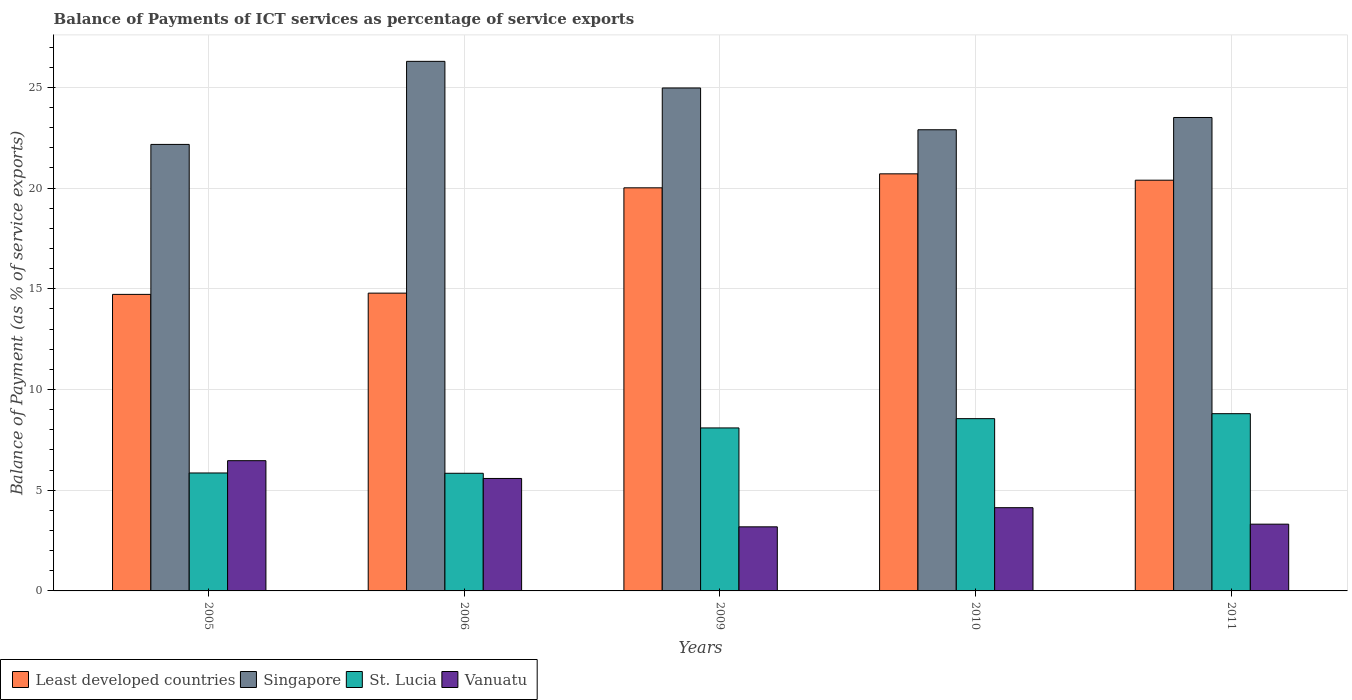How many different coloured bars are there?
Your response must be concise. 4. How many groups of bars are there?
Offer a terse response. 5. How many bars are there on the 4th tick from the left?
Offer a very short reply. 4. In how many cases, is the number of bars for a given year not equal to the number of legend labels?
Offer a very short reply. 0. What is the balance of payments of ICT services in Vanuatu in 2010?
Provide a short and direct response. 4.13. Across all years, what is the maximum balance of payments of ICT services in Vanuatu?
Give a very brief answer. 6.47. Across all years, what is the minimum balance of payments of ICT services in Vanuatu?
Your answer should be very brief. 3.18. In which year was the balance of payments of ICT services in Singapore minimum?
Make the answer very short. 2005. What is the total balance of payments of ICT services in Vanuatu in the graph?
Keep it short and to the point. 22.68. What is the difference between the balance of payments of ICT services in Singapore in 2006 and that in 2009?
Give a very brief answer. 1.32. What is the difference between the balance of payments of ICT services in St. Lucia in 2011 and the balance of payments of ICT services in Singapore in 2010?
Ensure brevity in your answer.  -14.1. What is the average balance of payments of ICT services in St. Lucia per year?
Ensure brevity in your answer.  7.43. In the year 2010, what is the difference between the balance of payments of ICT services in Least developed countries and balance of payments of ICT services in Singapore?
Ensure brevity in your answer.  -2.19. In how many years, is the balance of payments of ICT services in Singapore greater than 15 %?
Give a very brief answer. 5. What is the ratio of the balance of payments of ICT services in Least developed countries in 2009 to that in 2011?
Your answer should be very brief. 0.98. What is the difference between the highest and the second highest balance of payments of ICT services in Vanuatu?
Ensure brevity in your answer.  0.88. What is the difference between the highest and the lowest balance of payments of ICT services in Vanuatu?
Keep it short and to the point. 3.28. Is the sum of the balance of payments of ICT services in Least developed countries in 2006 and 2009 greater than the maximum balance of payments of ICT services in Vanuatu across all years?
Your answer should be compact. Yes. Is it the case that in every year, the sum of the balance of payments of ICT services in Singapore and balance of payments of ICT services in Least developed countries is greater than the sum of balance of payments of ICT services in Vanuatu and balance of payments of ICT services in St. Lucia?
Keep it short and to the point. No. What does the 2nd bar from the left in 2011 represents?
Your answer should be compact. Singapore. What does the 1st bar from the right in 2011 represents?
Keep it short and to the point. Vanuatu. Is it the case that in every year, the sum of the balance of payments of ICT services in Least developed countries and balance of payments of ICT services in Singapore is greater than the balance of payments of ICT services in Vanuatu?
Your answer should be compact. Yes. How many bars are there?
Your answer should be compact. 20. Are the values on the major ticks of Y-axis written in scientific E-notation?
Your answer should be very brief. No. Where does the legend appear in the graph?
Your answer should be compact. Bottom left. What is the title of the graph?
Your answer should be very brief. Balance of Payments of ICT services as percentage of service exports. What is the label or title of the X-axis?
Offer a terse response. Years. What is the label or title of the Y-axis?
Give a very brief answer. Balance of Payment (as % of service exports). What is the Balance of Payment (as % of service exports) in Least developed countries in 2005?
Give a very brief answer. 14.72. What is the Balance of Payment (as % of service exports) of Singapore in 2005?
Keep it short and to the point. 22.17. What is the Balance of Payment (as % of service exports) in St. Lucia in 2005?
Offer a terse response. 5.86. What is the Balance of Payment (as % of service exports) in Vanuatu in 2005?
Offer a very short reply. 6.47. What is the Balance of Payment (as % of service exports) of Least developed countries in 2006?
Your answer should be very brief. 14.78. What is the Balance of Payment (as % of service exports) in Singapore in 2006?
Give a very brief answer. 26.29. What is the Balance of Payment (as % of service exports) of St. Lucia in 2006?
Give a very brief answer. 5.84. What is the Balance of Payment (as % of service exports) in Vanuatu in 2006?
Ensure brevity in your answer.  5.58. What is the Balance of Payment (as % of service exports) of Least developed countries in 2009?
Ensure brevity in your answer.  20.01. What is the Balance of Payment (as % of service exports) in Singapore in 2009?
Offer a very short reply. 24.97. What is the Balance of Payment (as % of service exports) in St. Lucia in 2009?
Your answer should be very brief. 8.09. What is the Balance of Payment (as % of service exports) of Vanuatu in 2009?
Offer a terse response. 3.18. What is the Balance of Payment (as % of service exports) of Least developed countries in 2010?
Your answer should be very brief. 20.71. What is the Balance of Payment (as % of service exports) of Singapore in 2010?
Offer a very short reply. 22.9. What is the Balance of Payment (as % of service exports) in St. Lucia in 2010?
Provide a succinct answer. 8.55. What is the Balance of Payment (as % of service exports) of Vanuatu in 2010?
Offer a terse response. 4.13. What is the Balance of Payment (as % of service exports) in Least developed countries in 2011?
Ensure brevity in your answer.  20.39. What is the Balance of Payment (as % of service exports) in Singapore in 2011?
Your answer should be very brief. 23.5. What is the Balance of Payment (as % of service exports) of St. Lucia in 2011?
Offer a terse response. 8.8. What is the Balance of Payment (as % of service exports) in Vanuatu in 2011?
Provide a succinct answer. 3.31. Across all years, what is the maximum Balance of Payment (as % of service exports) of Least developed countries?
Provide a succinct answer. 20.71. Across all years, what is the maximum Balance of Payment (as % of service exports) of Singapore?
Your response must be concise. 26.29. Across all years, what is the maximum Balance of Payment (as % of service exports) in St. Lucia?
Your answer should be very brief. 8.8. Across all years, what is the maximum Balance of Payment (as % of service exports) in Vanuatu?
Keep it short and to the point. 6.47. Across all years, what is the minimum Balance of Payment (as % of service exports) of Least developed countries?
Offer a terse response. 14.72. Across all years, what is the minimum Balance of Payment (as % of service exports) of Singapore?
Keep it short and to the point. 22.17. Across all years, what is the minimum Balance of Payment (as % of service exports) in St. Lucia?
Provide a succinct answer. 5.84. Across all years, what is the minimum Balance of Payment (as % of service exports) in Vanuatu?
Your answer should be compact. 3.18. What is the total Balance of Payment (as % of service exports) of Least developed countries in the graph?
Your answer should be very brief. 90.62. What is the total Balance of Payment (as % of service exports) of Singapore in the graph?
Give a very brief answer. 119.83. What is the total Balance of Payment (as % of service exports) of St. Lucia in the graph?
Keep it short and to the point. 37.14. What is the total Balance of Payment (as % of service exports) of Vanuatu in the graph?
Your answer should be very brief. 22.68. What is the difference between the Balance of Payment (as % of service exports) of Least developed countries in 2005 and that in 2006?
Your answer should be very brief. -0.06. What is the difference between the Balance of Payment (as % of service exports) of Singapore in 2005 and that in 2006?
Provide a succinct answer. -4.12. What is the difference between the Balance of Payment (as % of service exports) of St. Lucia in 2005 and that in 2006?
Keep it short and to the point. 0.01. What is the difference between the Balance of Payment (as % of service exports) of Vanuatu in 2005 and that in 2006?
Keep it short and to the point. 0.88. What is the difference between the Balance of Payment (as % of service exports) of Least developed countries in 2005 and that in 2009?
Your answer should be compact. -5.29. What is the difference between the Balance of Payment (as % of service exports) of Singapore in 2005 and that in 2009?
Provide a succinct answer. -2.8. What is the difference between the Balance of Payment (as % of service exports) in St. Lucia in 2005 and that in 2009?
Offer a very short reply. -2.24. What is the difference between the Balance of Payment (as % of service exports) of Vanuatu in 2005 and that in 2009?
Keep it short and to the point. 3.28. What is the difference between the Balance of Payment (as % of service exports) of Least developed countries in 2005 and that in 2010?
Keep it short and to the point. -5.98. What is the difference between the Balance of Payment (as % of service exports) in Singapore in 2005 and that in 2010?
Give a very brief answer. -0.73. What is the difference between the Balance of Payment (as % of service exports) in St. Lucia in 2005 and that in 2010?
Keep it short and to the point. -2.7. What is the difference between the Balance of Payment (as % of service exports) of Vanuatu in 2005 and that in 2010?
Provide a succinct answer. 2.33. What is the difference between the Balance of Payment (as % of service exports) in Least developed countries in 2005 and that in 2011?
Provide a succinct answer. -5.67. What is the difference between the Balance of Payment (as % of service exports) of Singapore in 2005 and that in 2011?
Ensure brevity in your answer.  -1.34. What is the difference between the Balance of Payment (as % of service exports) of St. Lucia in 2005 and that in 2011?
Make the answer very short. -2.94. What is the difference between the Balance of Payment (as % of service exports) in Vanuatu in 2005 and that in 2011?
Offer a terse response. 3.15. What is the difference between the Balance of Payment (as % of service exports) of Least developed countries in 2006 and that in 2009?
Your answer should be very brief. -5.23. What is the difference between the Balance of Payment (as % of service exports) of Singapore in 2006 and that in 2009?
Provide a short and direct response. 1.32. What is the difference between the Balance of Payment (as % of service exports) in St. Lucia in 2006 and that in 2009?
Provide a succinct answer. -2.25. What is the difference between the Balance of Payment (as % of service exports) of Vanuatu in 2006 and that in 2009?
Give a very brief answer. 2.4. What is the difference between the Balance of Payment (as % of service exports) in Least developed countries in 2006 and that in 2010?
Your answer should be compact. -5.92. What is the difference between the Balance of Payment (as % of service exports) of Singapore in 2006 and that in 2010?
Provide a succinct answer. 3.4. What is the difference between the Balance of Payment (as % of service exports) in St. Lucia in 2006 and that in 2010?
Provide a short and direct response. -2.71. What is the difference between the Balance of Payment (as % of service exports) of Vanuatu in 2006 and that in 2010?
Ensure brevity in your answer.  1.45. What is the difference between the Balance of Payment (as % of service exports) of Least developed countries in 2006 and that in 2011?
Give a very brief answer. -5.61. What is the difference between the Balance of Payment (as % of service exports) in Singapore in 2006 and that in 2011?
Provide a succinct answer. 2.79. What is the difference between the Balance of Payment (as % of service exports) in St. Lucia in 2006 and that in 2011?
Your answer should be very brief. -2.96. What is the difference between the Balance of Payment (as % of service exports) in Vanuatu in 2006 and that in 2011?
Provide a short and direct response. 2.27. What is the difference between the Balance of Payment (as % of service exports) of Least developed countries in 2009 and that in 2010?
Make the answer very short. -0.69. What is the difference between the Balance of Payment (as % of service exports) in Singapore in 2009 and that in 2010?
Ensure brevity in your answer.  2.07. What is the difference between the Balance of Payment (as % of service exports) in St. Lucia in 2009 and that in 2010?
Your answer should be compact. -0.46. What is the difference between the Balance of Payment (as % of service exports) in Vanuatu in 2009 and that in 2010?
Offer a terse response. -0.95. What is the difference between the Balance of Payment (as % of service exports) of Least developed countries in 2009 and that in 2011?
Your answer should be compact. -0.38. What is the difference between the Balance of Payment (as % of service exports) of Singapore in 2009 and that in 2011?
Keep it short and to the point. 1.47. What is the difference between the Balance of Payment (as % of service exports) of St. Lucia in 2009 and that in 2011?
Give a very brief answer. -0.71. What is the difference between the Balance of Payment (as % of service exports) in Vanuatu in 2009 and that in 2011?
Your answer should be very brief. -0.13. What is the difference between the Balance of Payment (as % of service exports) in Least developed countries in 2010 and that in 2011?
Your answer should be compact. 0.32. What is the difference between the Balance of Payment (as % of service exports) of Singapore in 2010 and that in 2011?
Your response must be concise. -0.61. What is the difference between the Balance of Payment (as % of service exports) of St. Lucia in 2010 and that in 2011?
Provide a succinct answer. -0.25. What is the difference between the Balance of Payment (as % of service exports) in Vanuatu in 2010 and that in 2011?
Your response must be concise. 0.82. What is the difference between the Balance of Payment (as % of service exports) in Least developed countries in 2005 and the Balance of Payment (as % of service exports) in Singapore in 2006?
Your response must be concise. -11.57. What is the difference between the Balance of Payment (as % of service exports) of Least developed countries in 2005 and the Balance of Payment (as % of service exports) of St. Lucia in 2006?
Offer a very short reply. 8.88. What is the difference between the Balance of Payment (as % of service exports) of Least developed countries in 2005 and the Balance of Payment (as % of service exports) of Vanuatu in 2006?
Keep it short and to the point. 9.14. What is the difference between the Balance of Payment (as % of service exports) in Singapore in 2005 and the Balance of Payment (as % of service exports) in St. Lucia in 2006?
Make the answer very short. 16.33. What is the difference between the Balance of Payment (as % of service exports) in Singapore in 2005 and the Balance of Payment (as % of service exports) in Vanuatu in 2006?
Your answer should be compact. 16.58. What is the difference between the Balance of Payment (as % of service exports) in St. Lucia in 2005 and the Balance of Payment (as % of service exports) in Vanuatu in 2006?
Make the answer very short. 0.27. What is the difference between the Balance of Payment (as % of service exports) of Least developed countries in 2005 and the Balance of Payment (as % of service exports) of Singapore in 2009?
Offer a very short reply. -10.25. What is the difference between the Balance of Payment (as % of service exports) of Least developed countries in 2005 and the Balance of Payment (as % of service exports) of St. Lucia in 2009?
Keep it short and to the point. 6.63. What is the difference between the Balance of Payment (as % of service exports) in Least developed countries in 2005 and the Balance of Payment (as % of service exports) in Vanuatu in 2009?
Keep it short and to the point. 11.54. What is the difference between the Balance of Payment (as % of service exports) in Singapore in 2005 and the Balance of Payment (as % of service exports) in St. Lucia in 2009?
Ensure brevity in your answer.  14.08. What is the difference between the Balance of Payment (as % of service exports) in Singapore in 2005 and the Balance of Payment (as % of service exports) in Vanuatu in 2009?
Keep it short and to the point. 18.99. What is the difference between the Balance of Payment (as % of service exports) in St. Lucia in 2005 and the Balance of Payment (as % of service exports) in Vanuatu in 2009?
Make the answer very short. 2.67. What is the difference between the Balance of Payment (as % of service exports) of Least developed countries in 2005 and the Balance of Payment (as % of service exports) of Singapore in 2010?
Make the answer very short. -8.17. What is the difference between the Balance of Payment (as % of service exports) in Least developed countries in 2005 and the Balance of Payment (as % of service exports) in St. Lucia in 2010?
Your response must be concise. 6.17. What is the difference between the Balance of Payment (as % of service exports) in Least developed countries in 2005 and the Balance of Payment (as % of service exports) in Vanuatu in 2010?
Your answer should be very brief. 10.59. What is the difference between the Balance of Payment (as % of service exports) in Singapore in 2005 and the Balance of Payment (as % of service exports) in St. Lucia in 2010?
Provide a short and direct response. 13.61. What is the difference between the Balance of Payment (as % of service exports) of Singapore in 2005 and the Balance of Payment (as % of service exports) of Vanuatu in 2010?
Your answer should be very brief. 18.04. What is the difference between the Balance of Payment (as % of service exports) of St. Lucia in 2005 and the Balance of Payment (as % of service exports) of Vanuatu in 2010?
Your answer should be compact. 1.72. What is the difference between the Balance of Payment (as % of service exports) in Least developed countries in 2005 and the Balance of Payment (as % of service exports) in Singapore in 2011?
Provide a short and direct response. -8.78. What is the difference between the Balance of Payment (as % of service exports) of Least developed countries in 2005 and the Balance of Payment (as % of service exports) of St. Lucia in 2011?
Your answer should be compact. 5.92. What is the difference between the Balance of Payment (as % of service exports) in Least developed countries in 2005 and the Balance of Payment (as % of service exports) in Vanuatu in 2011?
Ensure brevity in your answer.  11.41. What is the difference between the Balance of Payment (as % of service exports) in Singapore in 2005 and the Balance of Payment (as % of service exports) in St. Lucia in 2011?
Keep it short and to the point. 13.37. What is the difference between the Balance of Payment (as % of service exports) in Singapore in 2005 and the Balance of Payment (as % of service exports) in Vanuatu in 2011?
Your response must be concise. 18.85. What is the difference between the Balance of Payment (as % of service exports) in St. Lucia in 2005 and the Balance of Payment (as % of service exports) in Vanuatu in 2011?
Offer a very short reply. 2.54. What is the difference between the Balance of Payment (as % of service exports) of Least developed countries in 2006 and the Balance of Payment (as % of service exports) of Singapore in 2009?
Make the answer very short. -10.19. What is the difference between the Balance of Payment (as % of service exports) of Least developed countries in 2006 and the Balance of Payment (as % of service exports) of St. Lucia in 2009?
Provide a short and direct response. 6.69. What is the difference between the Balance of Payment (as % of service exports) of Least developed countries in 2006 and the Balance of Payment (as % of service exports) of Vanuatu in 2009?
Provide a short and direct response. 11.6. What is the difference between the Balance of Payment (as % of service exports) in Singapore in 2006 and the Balance of Payment (as % of service exports) in St. Lucia in 2009?
Your answer should be very brief. 18.2. What is the difference between the Balance of Payment (as % of service exports) in Singapore in 2006 and the Balance of Payment (as % of service exports) in Vanuatu in 2009?
Ensure brevity in your answer.  23.11. What is the difference between the Balance of Payment (as % of service exports) of St. Lucia in 2006 and the Balance of Payment (as % of service exports) of Vanuatu in 2009?
Your answer should be compact. 2.66. What is the difference between the Balance of Payment (as % of service exports) of Least developed countries in 2006 and the Balance of Payment (as % of service exports) of Singapore in 2010?
Provide a succinct answer. -8.11. What is the difference between the Balance of Payment (as % of service exports) in Least developed countries in 2006 and the Balance of Payment (as % of service exports) in St. Lucia in 2010?
Give a very brief answer. 6.23. What is the difference between the Balance of Payment (as % of service exports) of Least developed countries in 2006 and the Balance of Payment (as % of service exports) of Vanuatu in 2010?
Keep it short and to the point. 10.65. What is the difference between the Balance of Payment (as % of service exports) in Singapore in 2006 and the Balance of Payment (as % of service exports) in St. Lucia in 2010?
Your answer should be very brief. 17.74. What is the difference between the Balance of Payment (as % of service exports) in Singapore in 2006 and the Balance of Payment (as % of service exports) in Vanuatu in 2010?
Offer a very short reply. 22.16. What is the difference between the Balance of Payment (as % of service exports) in St. Lucia in 2006 and the Balance of Payment (as % of service exports) in Vanuatu in 2010?
Your response must be concise. 1.71. What is the difference between the Balance of Payment (as % of service exports) of Least developed countries in 2006 and the Balance of Payment (as % of service exports) of Singapore in 2011?
Your response must be concise. -8.72. What is the difference between the Balance of Payment (as % of service exports) of Least developed countries in 2006 and the Balance of Payment (as % of service exports) of St. Lucia in 2011?
Offer a terse response. 5.99. What is the difference between the Balance of Payment (as % of service exports) in Least developed countries in 2006 and the Balance of Payment (as % of service exports) in Vanuatu in 2011?
Make the answer very short. 11.47. What is the difference between the Balance of Payment (as % of service exports) of Singapore in 2006 and the Balance of Payment (as % of service exports) of St. Lucia in 2011?
Keep it short and to the point. 17.49. What is the difference between the Balance of Payment (as % of service exports) of Singapore in 2006 and the Balance of Payment (as % of service exports) of Vanuatu in 2011?
Provide a short and direct response. 22.98. What is the difference between the Balance of Payment (as % of service exports) in St. Lucia in 2006 and the Balance of Payment (as % of service exports) in Vanuatu in 2011?
Offer a terse response. 2.53. What is the difference between the Balance of Payment (as % of service exports) of Least developed countries in 2009 and the Balance of Payment (as % of service exports) of Singapore in 2010?
Your response must be concise. -2.88. What is the difference between the Balance of Payment (as % of service exports) of Least developed countries in 2009 and the Balance of Payment (as % of service exports) of St. Lucia in 2010?
Keep it short and to the point. 11.46. What is the difference between the Balance of Payment (as % of service exports) in Least developed countries in 2009 and the Balance of Payment (as % of service exports) in Vanuatu in 2010?
Provide a short and direct response. 15.88. What is the difference between the Balance of Payment (as % of service exports) in Singapore in 2009 and the Balance of Payment (as % of service exports) in St. Lucia in 2010?
Provide a succinct answer. 16.42. What is the difference between the Balance of Payment (as % of service exports) in Singapore in 2009 and the Balance of Payment (as % of service exports) in Vanuatu in 2010?
Keep it short and to the point. 20.84. What is the difference between the Balance of Payment (as % of service exports) of St. Lucia in 2009 and the Balance of Payment (as % of service exports) of Vanuatu in 2010?
Your answer should be very brief. 3.96. What is the difference between the Balance of Payment (as % of service exports) in Least developed countries in 2009 and the Balance of Payment (as % of service exports) in Singapore in 2011?
Your answer should be very brief. -3.49. What is the difference between the Balance of Payment (as % of service exports) of Least developed countries in 2009 and the Balance of Payment (as % of service exports) of St. Lucia in 2011?
Your answer should be compact. 11.21. What is the difference between the Balance of Payment (as % of service exports) of Least developed countries in 2009 and the Balance of Payment (as % of service exports) of Vanuatu in 2011?
Ensure brevity in your answer.  16.7. What is the difference between the Balance of Payment (as % of service exports) in Singapore in 2009 and the Balance of Payment (as % of service exports) in St. Lucia in 2011?
Your answer should be compact. 16.17. What is the difference between the Balance of Payment (as % of service exports) of Singapore in 2009 and the Balance of Payment (as % of service exports) of Vanuatu in 2011?
Offer a terse response. 21.66. What is the difference between the Balance of Payment (as % of service exports) in St. Lucia in 2009 and the Balance of Payment (as % of service exports) in Vanuatu in 2011?
Your answer should be very brief. 4.78. What is the difference between the Balance of Payment (as % of service exports) in Least developed countries in 2010 and the Balance of Payment (as % of service exports) in Singapore in 2011?
Offer a terse response. -2.8. What is the difference between the Balance of Payment (as % of service exports) of Least developed countries in 2010 and the Balance of Payment (as % of service exports) of St. Lucia in 2011?
Ensure brevity in your answer.  11.91. What is the difference between the Balance of Payment (as % of service exports) in Least developed countries in 2010 and the Balance of Payment (as % of service exports) in Vanuatu in 2011?
Your answer should be very brief. 17.39. What is the difference between the Balance of Payment (as % of service exports) of Singapore in 2010 and the Balance of Payment (as % of service exports) of St. Lucia in 2011?
Offer a very short reply. 14.1. What is the difference between the Balance of Payment (as % of service exports) in Singapore in 2010 and the Balance of Payment (as % of service exports) in Vanuatu in 2011?
Your answer should be compact. 19.58. What is the difference between the Balance of Payment (as % of service exports) of St. Lucia in 2010 and the Balance of Payment (as % of service exports) of Vanuatu in 2011?
Your response must be concise. 5.24. What is the average Balance of Payment (as % of service exports) of Least developed countries per year?
Offer a terse response. 18.12. What is the average Balance of Payment (as % of service exports) of Singapore per year?
Provide a succinct answer. 23.97. What is the average Balance of Payment (as % of service exports) in St. Lucia per year?
Provide a succinct answer. 7.43. What is the average Balance of Payment (as % of service exports) of Vanuatu per year?
Ensure brevity in your answer.  4.54. In the year 2005, what is the difference between the Balance of Payment (as % of service exports) of Least developed countries and Balance of Payment (as % of service exports) of Singapore?
Keep it short and to the point. -7.45. In the year 2005, what is the difference between the Balance of Payment (as % of service exports) in Least developed countries and Balance of Payment (as % of service exports) in St. Lucia?
Offer a very short reply. 8.87. In the year 2005, what is the difference between the Balance of Payment (as % of service exports) in Least developed countries and Balance of Payment (as % of service exports) in Vanuatu?
Keep it short and to the point. 8.26. In the year 2005, what is the difference between the Balance of Payment (as % of service exports) in Singapore and Balance of Payment (as % of service exports) in St. Lucia?
Offer a terse response. 16.31. In the year 2005, what is the difference between the Balance of Payment (as % of service exports) of Singapore and Balance of Payment (as % of service exports) of Vanuatu?
Make the answer very short. 15.7. In the year 2005, what is the difference between the Balance of Payment (as % of service exports) of St. Lucia and Balance of Payment (as % of service exports) of Vanuatu?
Ensure brevity in your answer.  -0.61. In the year 2006, what is the difference between the Balance of Payment (as % of service exports) of Least developed countries and Balance of Payment (as % of service exports) of Singapore?
Keep it short and to the point. -11.51. In the year 2006, what is the difference between the Balance of Payment (as % of service exports) in Least developed countries and Balance of Payment (as % of service exports) in St. Lucia?
Provide a succinct answer. 8.94. In the year 2006, what is the difference between the Balance of Payment (as % of service exports) of Least developed countries and Balance of Payment (as % of service exports) of Vanuatu?
Provide a short and direct response. 9.2. In the year 2006, what is the difference between the Balance of Payment (as % of service exports) in Singapore and Balance of Payment (as % of service exports) in St. Lucia?
Your answer should be very brief. 20.45. In the year 2006, what is the difference between the Balance of Payment (as % of service exports) in Singapore and Balance of Payment (as % of service exports) in Vanuatu?
Give a very brief answer. 20.71. In the year 2006, what is the difference between the Balance of Payment (as % of service exports) in St. Lucia and Balance of Payment (as % of service exports) in Vanuatu?
Your answer should be compact. 0.26. In the year 2009, what is the difference between the Balance of Payment (as % of service exports) in Least developed countries and Balance of Payment (as % of service exports) in Singapore?
Make the answer very short. -4.96. In the year 2009, what is the difference between the Balance of Payment (as % of service exports) of Least developed countries and Balance of Payment (as % of service exports) of St. Lucia?
Make the answer very short. 11.92. In the year 2009, what is the difference between the Balance of Payment (as % of service exports) in Least developed countries and Balance of Payment (as % of service exports) in Vanuatu?
Offer a very short reply. 16.83. In the year 2009, what is the difference between the Balance of Payment (as % of service exports) in Singapore and Balance of Payment (as % of service exports) in St. Lucia?
Your response must be concise. 16.88. In the year 2009, what is the difference between the Balance of Payment (as % of service exports) of Singapore and Balance of Payment (as % of service exports) of Vanuatu?
Provide a short and direct response. 21.79. In the year 2009, what is the difference between the Balance of Payment (as % of service exports) of St. Lucia and Balance of Payment (as % of service exports) of Vanuatu?
Your answer should be compact. 4.91. In the year 2010, what is the difference between the Balance of Payment (as % of service exports) of Least developed countries and Balance of Payment (as % of service exports) of Singapore?
Offer a terse response. -2.19. In the year 2010, what is the difference between the Balance of Payment (as % of service exports) in Least developed countries and Balance of Payment (as % of service exports) in St. Lucia?
Your response must be concise. 12.15. In the year 2010, what is the difference between the Balance of Payment (as % of service exports) in Least developed countries and Balance of Payment (as % of service exports) in Vanuatu?
Provide a short and direct response. 16.57. In the year 2010, what is the difference between the Balance of Payment (as % of service exports) of Singapore and Balance of Payment (as % of service exports) of St. Lucia?
Provide a succinct answer. 14.34. In the year 2010, what is the difference between the Balance of Payment (as % of service exports) of Singapore and Balance of Payment (as % of service exports) of Vanuatu?
Your answer should be very brief. 18.76. In the year 2010, what is the difference between the Balance of Payment (as % of service exports) in St. Lucia and Balance of Payment (as % of service exports) in Vanuatu?
Keep it short and to the point. 4.42. In the year 2011, what is the difference between the Balance of Payment (as % of service exports) of Least developed countries and Balance of Payment (as % of service exports) of Singapore?
Give a very brief answer. -3.11. In the year 2011, what is the difference between the Balance of Payment (as % of service exports) of Least developed countries and Balance of Payment (as % of service exports) of St. Lucia?
Offer a terse response. 11.59. In the year 2011, what is the difference between the Balance of Payment (as % of service exports) in Least developed countries and Balance of Payment (as % of service exports) in Vanuatu?
Provide a succinct answer. 17.08. In the year 2011, what is the difference between the Balance of Payment (as % of service exports) in Singapore and Balance of Payment (as % of service exports) in St. Lucia?
Give a very brief answer. 14.71. In the year 2011, what is the difference between the Balance of Payment (as % of service exports) in Singapore and Balance of Payment (as % of service exports) in Vanuatu?
Your response must be concise. 20.19. In the year 2011, what is the difference between the Balance of Payment (as % of service exports) of St. Lucia and Balance of Payment (as % of service exports) of Vanuatu?
Offer a very short reply. 5.48. What is the ratio of the Balance of Payment (as % of service exports) of Singapore in 2005 to that in 2006?
Ensure brevity in your answer.  0.84. What is the ratio of the Balance of Payment (as % of service exports) of St. Lucia in 2005 to that in 2006?
Provide a succinct answer. 1. What is the ratio of the Balance of Payment (as % of service exports) of Vanuatu in 2005 to that in 2006?
Ensure brevity in your answer.  1.16. What is the ratio of the Balance of Payment (as % of service exports) of Least developed countries in 2005 to that in 2009?
Your answer should be compact. 0.74. What is the ratio of the Balance of Payment (as % of service exports) of Singapore in 2005 to that in 2009?
Give a very brief answer. 0.89. What is the ratio of the Balance of Payment (as % of service exports) in St. Lucia in 2005 to that in 2009?
Make the answer very short. 0.72. What is the ratio of the Balance of Payment (as % of service exports) of Vanuatu in 2005 to that in 2009?
Give a very brief answer. 2.03. What is the ratio of the Balance of Payment (as % of service exports) of Least developed countries in 2005 to that in 2010?
Your response must be concise. 0.71. What is the ratio of the Balance of Payment (as % of service exports) of Singapore in 2005 to that in 2010?
Offer a terse response. 0.97. What is the ratio of the Balance of Payment (as % of service exports) in St. Lucia in 2005 to that in 2010?
Offer a very short reply. 0.68. What is the ratio of the Balance of Payment (as % of service exports) of Vanuatu in 2005 to that in 2010?
Your response must be concise. 1.56. What is the ratio of the Balance of Payment (as % of service exports) in Least developed countries in 2005 to that in 2011?
Ensure brevity in your answer.  0.72. What is the ratio of the Balance of Payment (as % of service exports) in Singapore in 2005 to that in 2011?
Keep it short and to the point. 0.94. What is the ratio of the Balance of Payment (as % of service exports) in St. Lucia in 2005 to that in 2011?
Provide a succinct answer. 0.67. What is the ratio of the Balance of Payment (as % of service exports) in Vanuatu in 2005 to that in 2011?
Keep it short and to the point. 1.95. What is the ratio of the Balance of Payment (as % of service exports) of Least developed countries in 2006 to that in 2009?
Provide a succinct answer. 0.74. What is the ratio of the Balance of Payment (as % of service exports) in Singapore in 2006 to that in 2009?
Provide a short and direct response. 1.05. What is the ratio of the Balance of Payment (as % of service exports) in St. Lucia in 2006 to that in 2009?
Offer a very short reply. 0.72. What is the ratio of the Balance of Payment (as % of service exports) of Vanuatu in 2006 to that in 2009?
Give a very brief answer. 1.75. What is the ratio of the Balance of Payment (as % of service exports) of Least developed countries in 2006 to that in 2010?
Provide a short and direct response. 0.71. What is the ratio of the Balance of Payment (as % of service exports) in Singapore in 2006 to that in 2010?
Your answer should be compact. 1.15. What is the ratio of the Balance of Payment (as % of service exports) of St. Lucia in 2006 to that in 2010?
Give a very brief answer. 0.68. What is the ratio of the Balance of Payment (as % of service exports) of Vanuatu in 2006 to that in 2010?
Provide a short and direct response. 1.35. What is the ratio of the Balance of Payment (as % of service exports) of Least developed countries in 2006 to that in 2011?
Offer a terse response. 0.72. What is the ratio of the Balance of Payment (as % of service exports) in Singapore in 2006 to that in 2011?
Give a very brief answer. 1.12. What is the ratio of the Balance of Payment (as % of service exports) in St. Lucia in 2006 to that in 2011?
Make the answer very short. 0.66. What is the ratio of the Balance of Payment (as % of service exports) of Vanuatu in 2006 to that in 2011?
Keep it short and to the point. 1.68. What is the ratio of the Balance of Payment (as % of service exports) of Least developed countries in 2009 to that in 2010?
Your response must be concise. 0.97. What is the ratio of the Balance of Payment (as % of service exports) in Singapore in 2009 to that in 2010?
Make the answer very short. 1.09. What is the ratio of the Balance of Payment (as % of service exports) in St. Lucia in 2009 to that in 2010?
Provide a succinct answer. 0.95. What is the ratio of the Balance of Payment (as % of service exports) of Vanuatu in 2009 to that in 2010?
Your response must be concise. 0.77. What is the ratio of the Balance of Payment (as % of service exports) of Least developed countries in 2009 to that in 2011?
Provide a succinct answer. 0.98. What is the ratio of the Balance of Payment (as % of service exports) of Singapore in 2009 to that in 2011?
Ensure brevity in your answer.  1.06. What is the ratio of the Balance of Payment (as % of service exports) in St. Lucia in 2009 to that in 2011?
Your response must be concise. 0.92. What is the ratio of the Balance of Payment (as % of service exports) of Vanuatu in 2009 to that in 2011?
Ensure brevity in your answer.  0.96. What is the ratio of the Balance of Payment (as % of service exports) of Least developed countries in 2010 to that in 2011?
Give a very brief answer. 1.02. What is the ratio of the Balance of Payment (as % of service exports) of Singapore in 2010 to that in 2011?
Offer a very short reply. 0.97. What is the ratio of the Balance of Payment (as % of service exports) in Vanuatu in 2010 to that in 2011?
Provide a short and direct response. 1.25. What is the difference between the highest and the second highest Balance of Payment (as % of service exports) of Least developed countries?
Offer a very short reply. 0.32. What is the difference between the highest and the second highest Balance of Payment (as % of service exports) of Singapore?
Your response must be concise. 1.32. What is the difference between the highest and the second highest Balance of Payment (as % of service exports) of St. Lucia?
Provide a succinct answer. 0.25. What is the difference between the highest and the second highest Balance of Payment (as % of service exports) in Vanuatu?
Your answer should be very brief. 0.88. What is the difference between the highest and the lowest Balance of Payment (as % of service exports) in Least developed countries?
Provide a short and direct response. 5.98. What is the difference between the highest and the lowest Balance of Payment (as % of service exports) in Singapore?
Provide a succinct answer. 4.12. What is the difference between the highest and the lowest Balance of Payment (as % of service exports) of St. Lucia?
Offer a very short reply. 2.96. What is the difference between the highest and the lowest Balance of Payment (as % of service exports) in Vanuatu?
Ensure brevity in your answer.  3.28. 